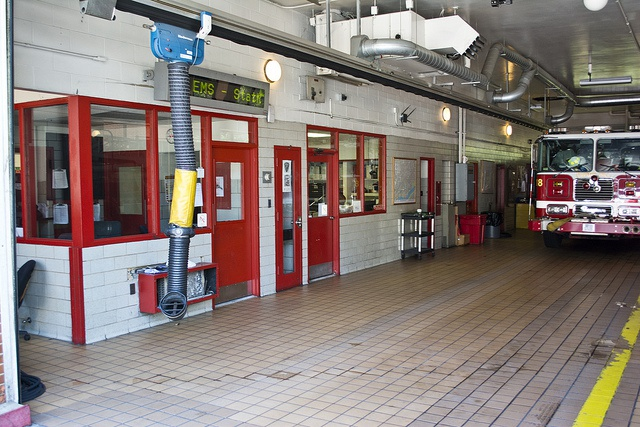Describe the objects in this image and their specific colors. I can see truck in white, black, lightgray, gray, and darkgray tones and chair in white, black, blue, purple, and maroon tones in this image. 